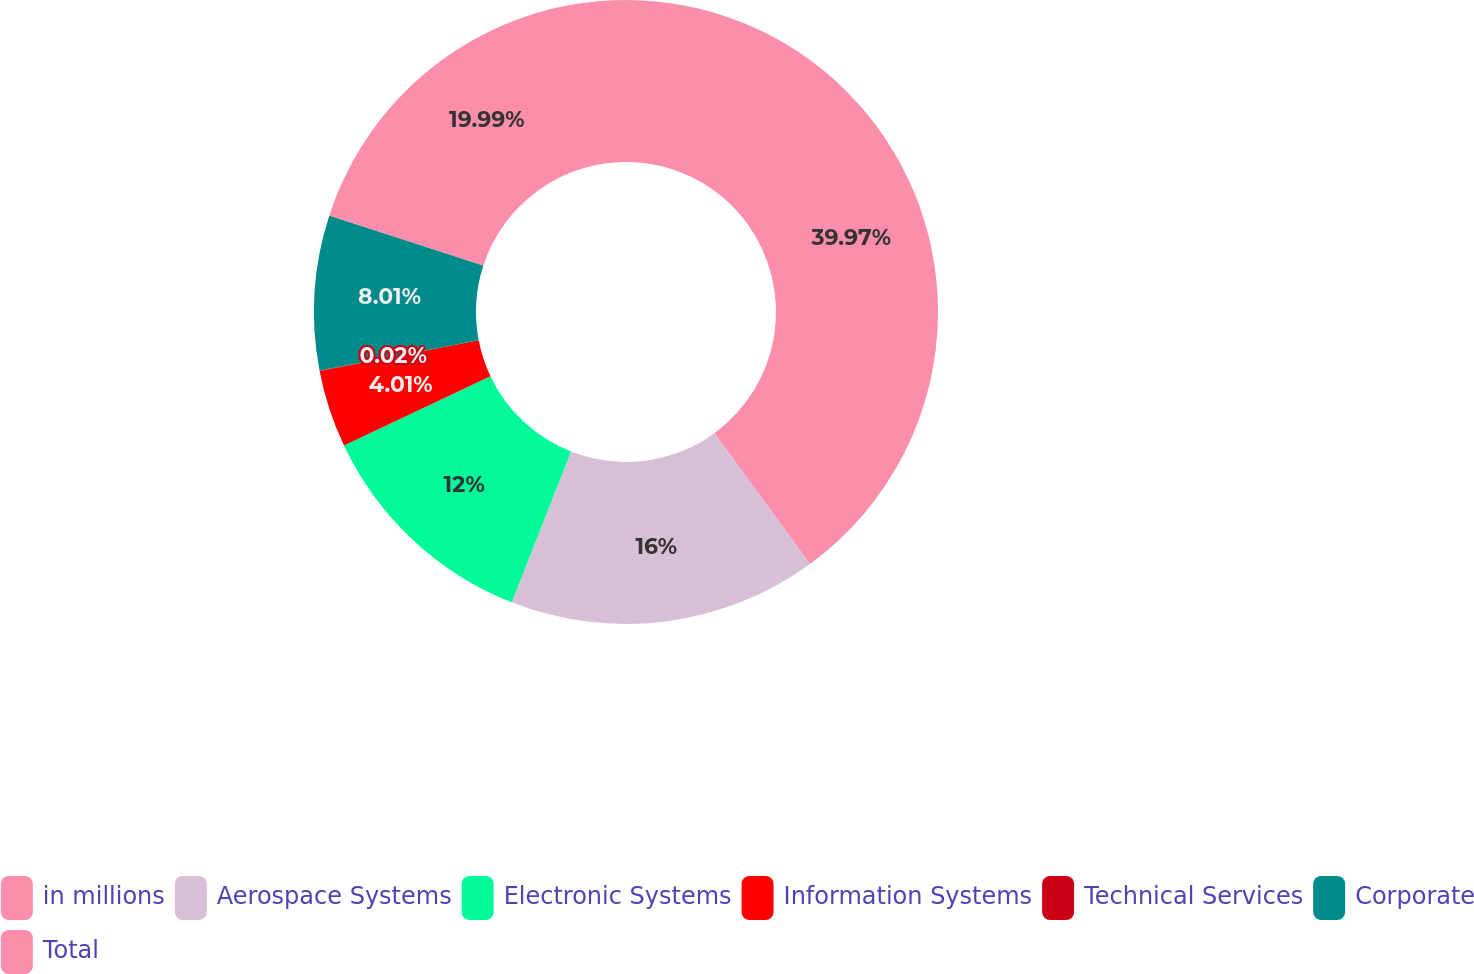Convert chart. <chart><loc_0><loc_0><loc_500><loc_500><pie_chart><fcel>in millions<fcel>Aerospace Systems<fcel>Electronic Systems<fcel>Information Systems<fcel>Technical Services<fcel>Corporate<fcel>Total<nl><fcel>39.96%<fcel>16.0%<fcel>12.0%<fcel>4.01%<fcel>0.02%<fcel>8.01%<fcel>19.99%<nl></chart> 